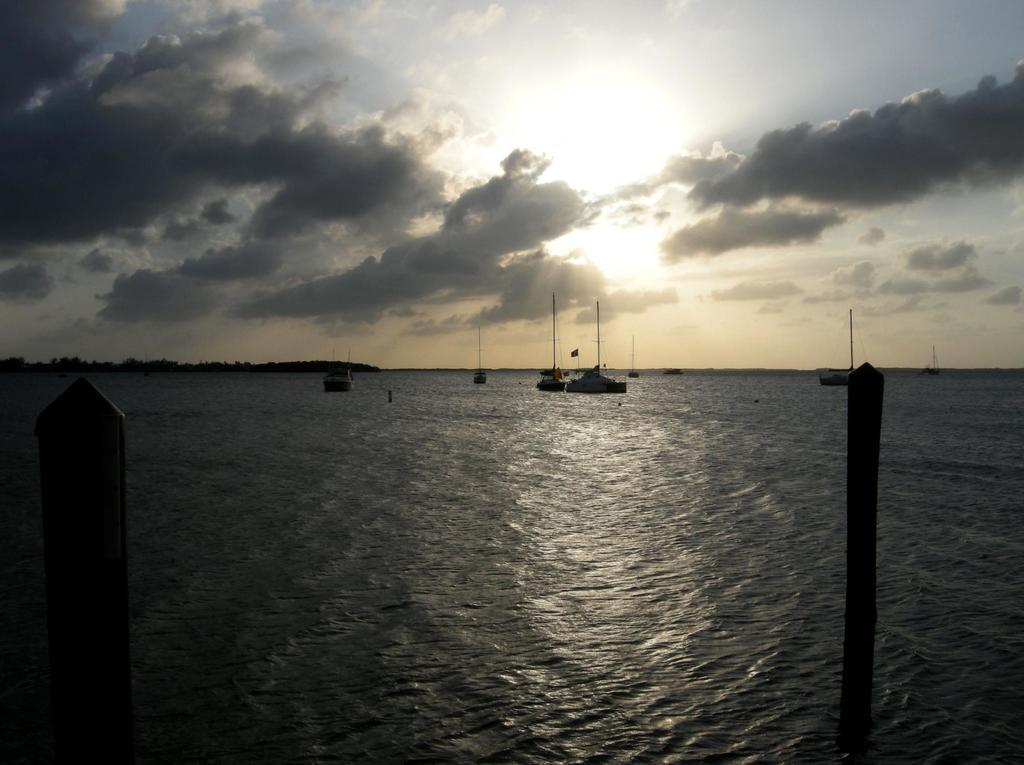What is the main element in the image? There is water in the image. What is floating on the water? There are boats on the water. What structures can be seen in the image? There are poles in the image. What is visible in the background of the image? The sky is visible in the background of the image. What can be seen in the sky? Clouds are present in the sky. How many letters are floating in the water in the image? There are no letters present in the image; it only features water, boats, poles, and clouds. Are there any jellyfish visible in the water in the image? There are no jellyfish present in the image; it only features water, boats, and poles. 